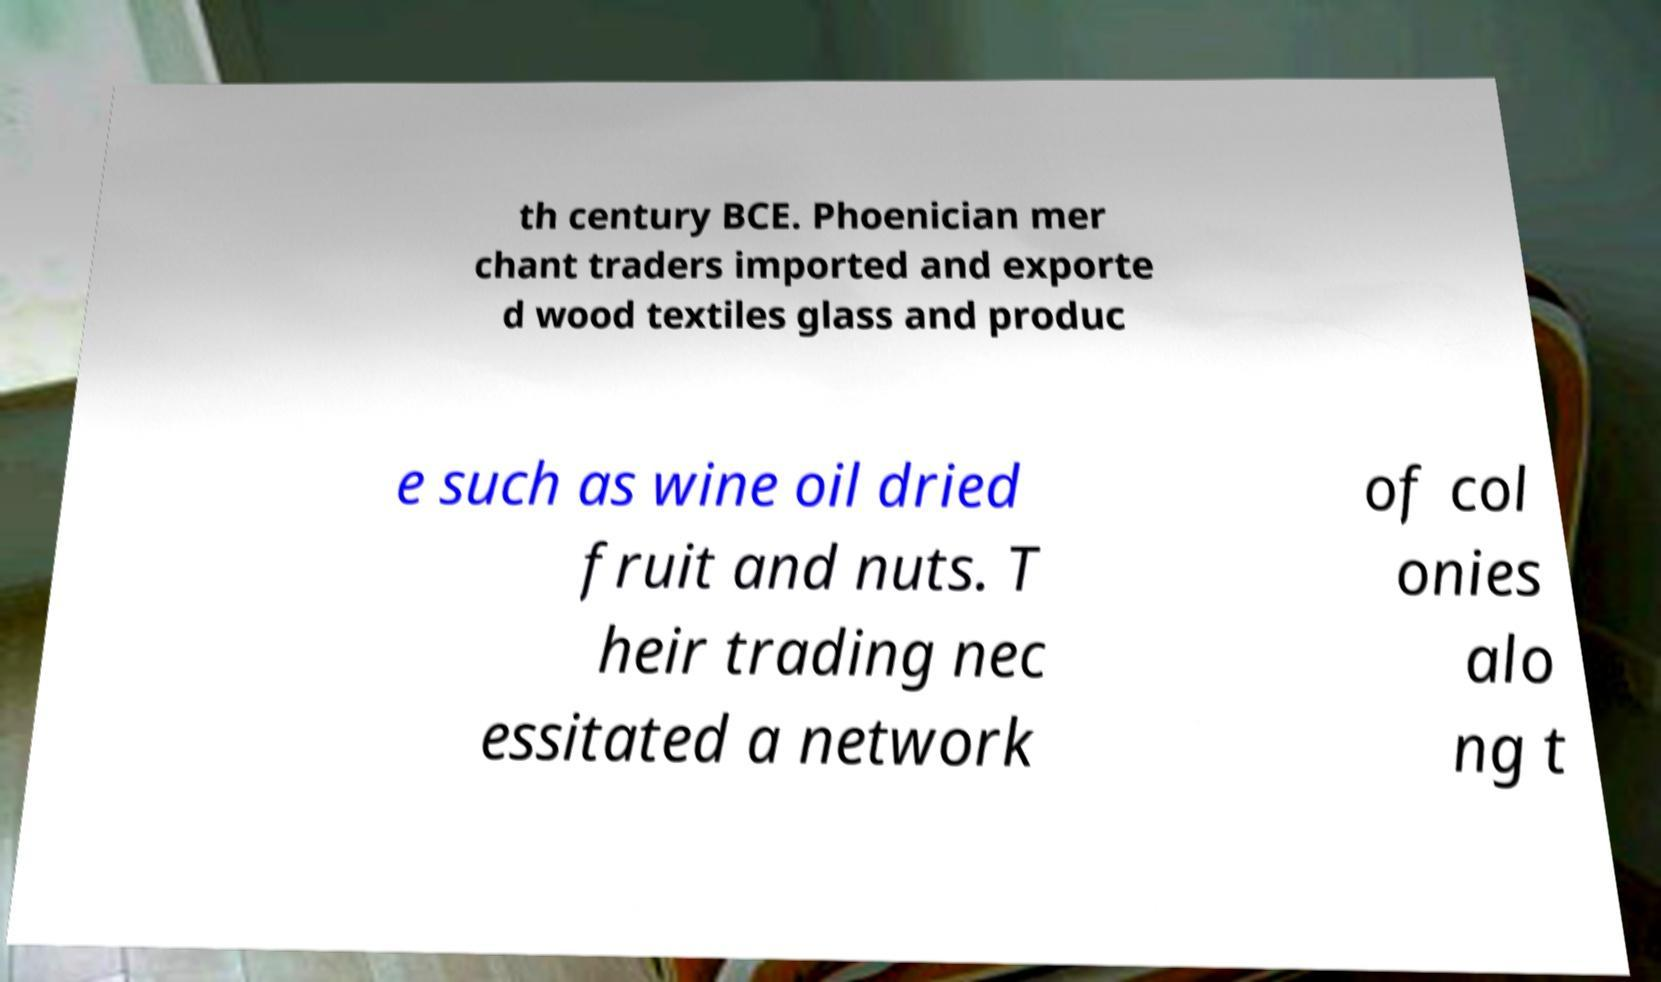Could you extract and type out the text from this image? th century BCE. Phoenician mer chant traders imported and exporte d wood textiles glass and produc e such as wine oil dried fruit and nuts. T heir trading nec essitated a network of col onies alo ng t 